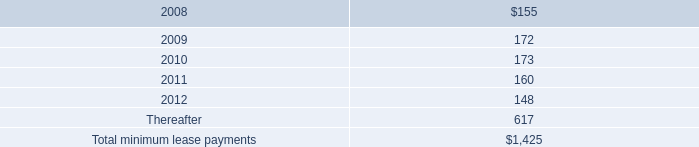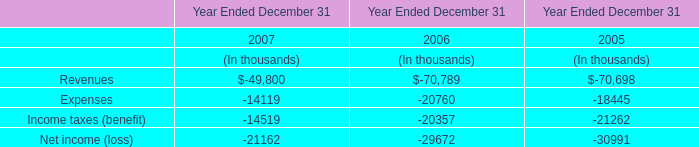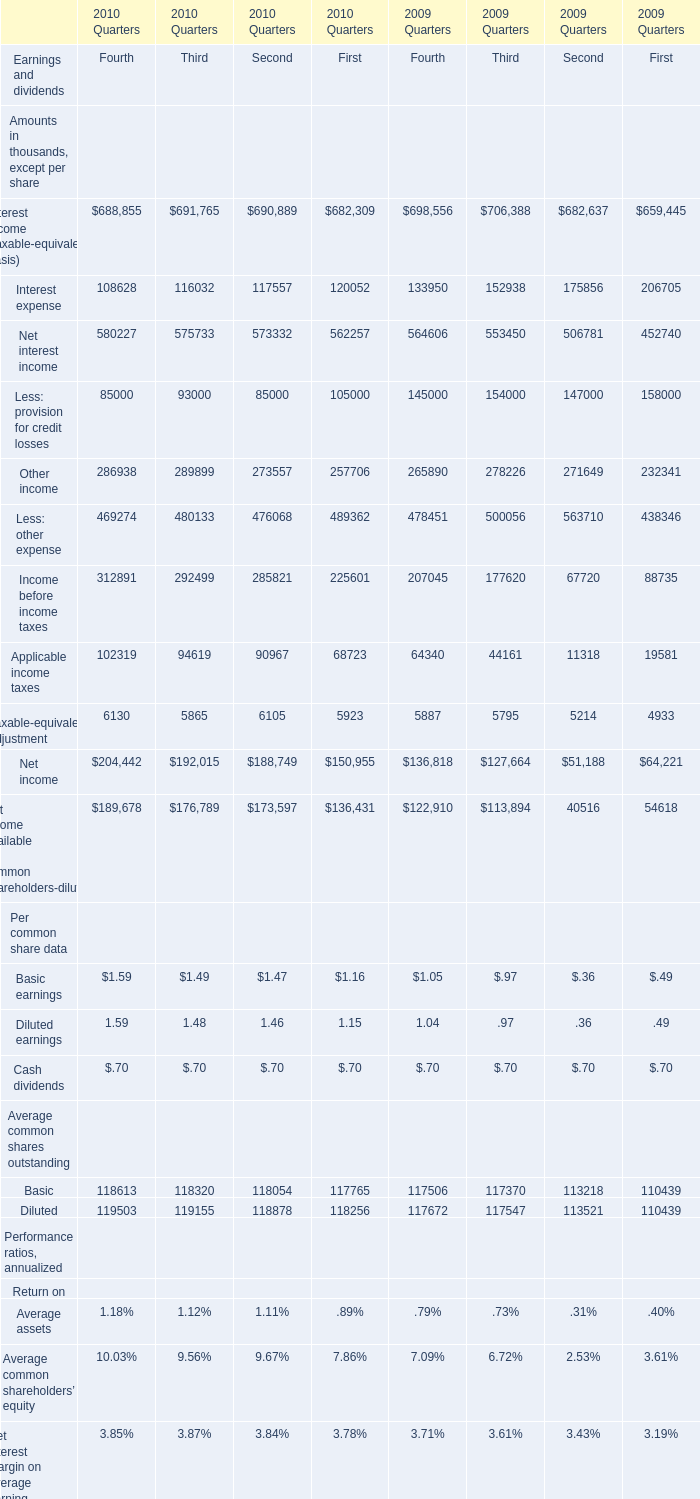At end of quarter what of 2009 is Earning assets the most? 
Answer: 2. 